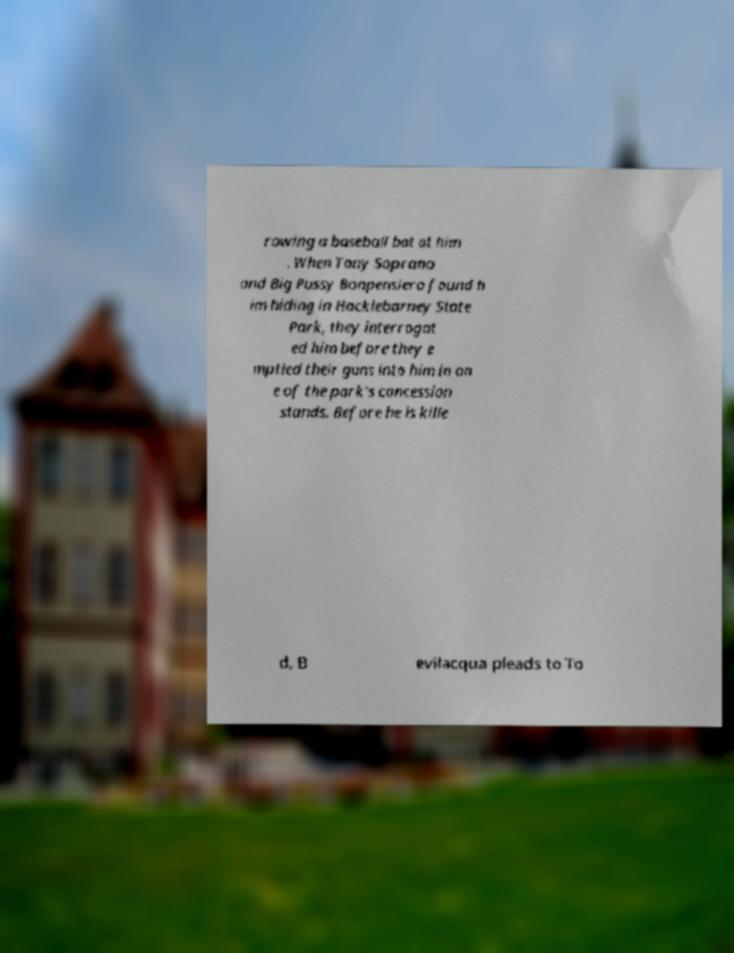Can you read and provide the text displayed in the image?This photo seems to have some interesting text. Can you extract and type it out for me? rowing a baseball bat at him . When Tony Soprano and Big Pussy Bonpensiero found h im hiding in Hacklebarney State Park, they interrogat ed him before they e mptied their guns into him in on e of the park's concession stands. Before he is kille d, B evilacqua pleads to To 